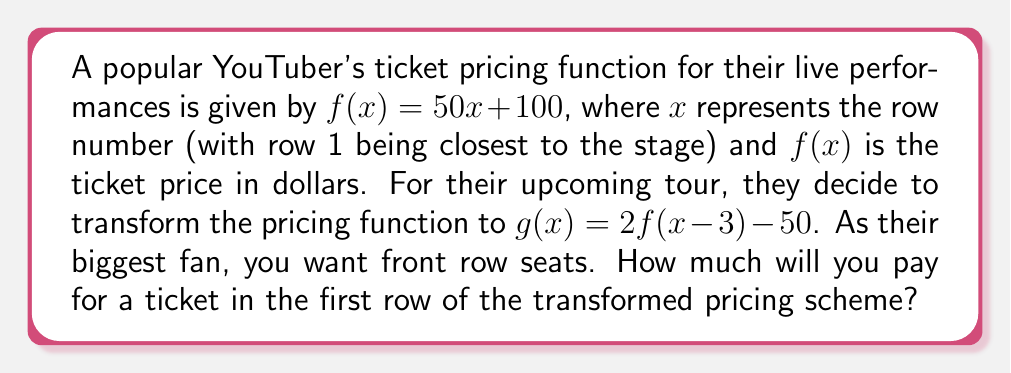Teach me how to tackle this problem. Let's approach this step-by-step:

1) We start with the original function $f(x) = 50x + 100$

2) The new function $g(x)$ is a transformation of $f(x)$:
   $g(x) = 2f(x-3) - 50$

3) To find the price of the first row ticket, we need to calculate $g(1)$:
   $g(1) = 2f(1-3) - 50$

4) Let's simplify the input of $f$ first:
   $1-3 = -2$
   So, $g(1) = 2f(-2) - 50$

5) Now, let's calculate $f(-2)$:
   $f(-2) = 50(-2) + 100 = -100 + 100 = 0$

6) Substituting this back into our equation for $g(1)$:
   $g(1) = 2(0) - 50 = -50$

7) However, ticket prices can't be negative. The question is asking about a real-world scenario, so we need to consider that the minimum ticket price would be $0.

Therefore, the ticket price for the first row under the new pricing scheme would be $0.
Answer: $0 